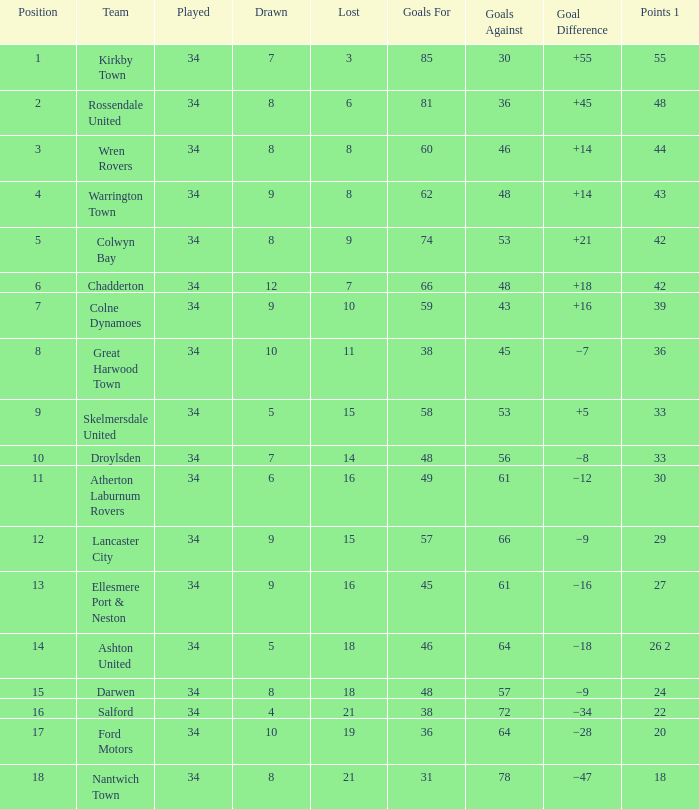What is the total number of positions when there are more than 48 goals against, 1 of 29 points are played, and less than 34 games have been played? 0.0. 